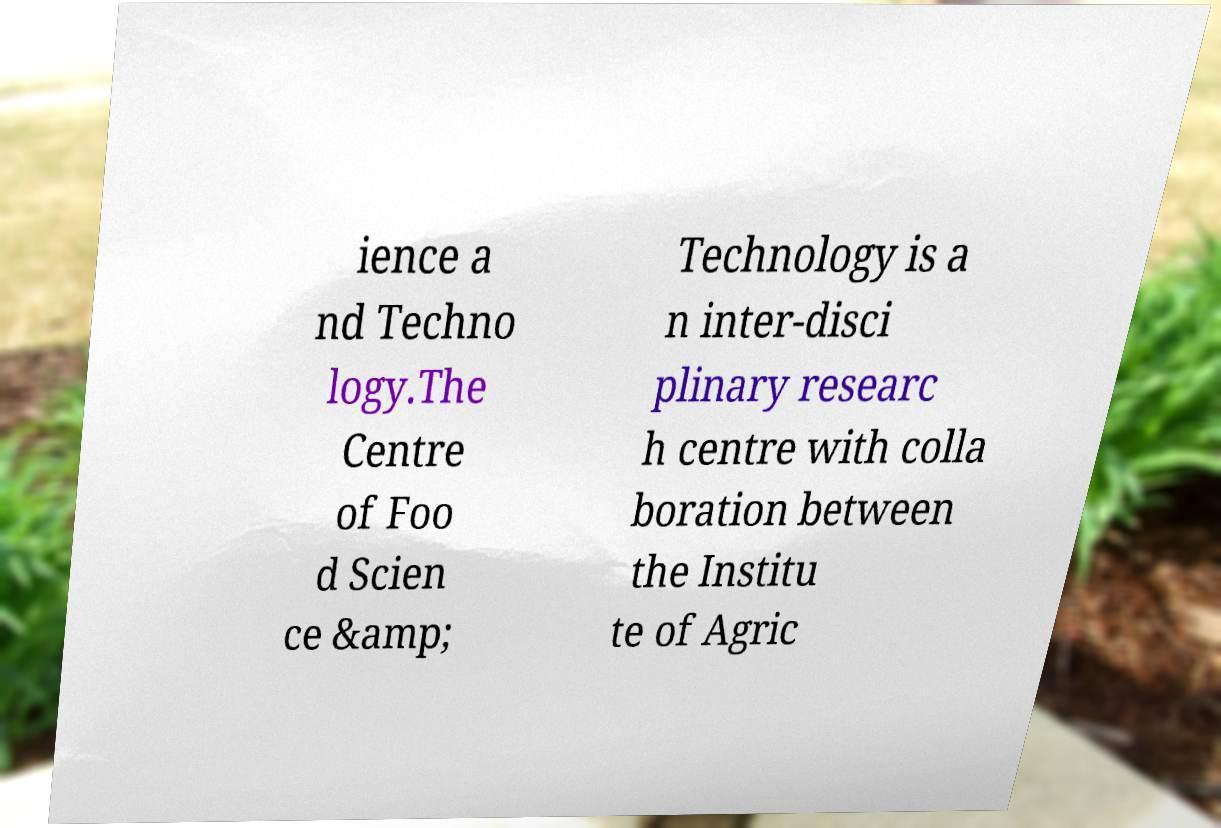For documentation purposes, I need the text within this image transcribed. Could you provide that? ience a nd Techno logy.The Centre of Foo d Scien ce &amp; Technology is a n inter-disci plinary researc h centre with colla boration between the Institu te of Agric 